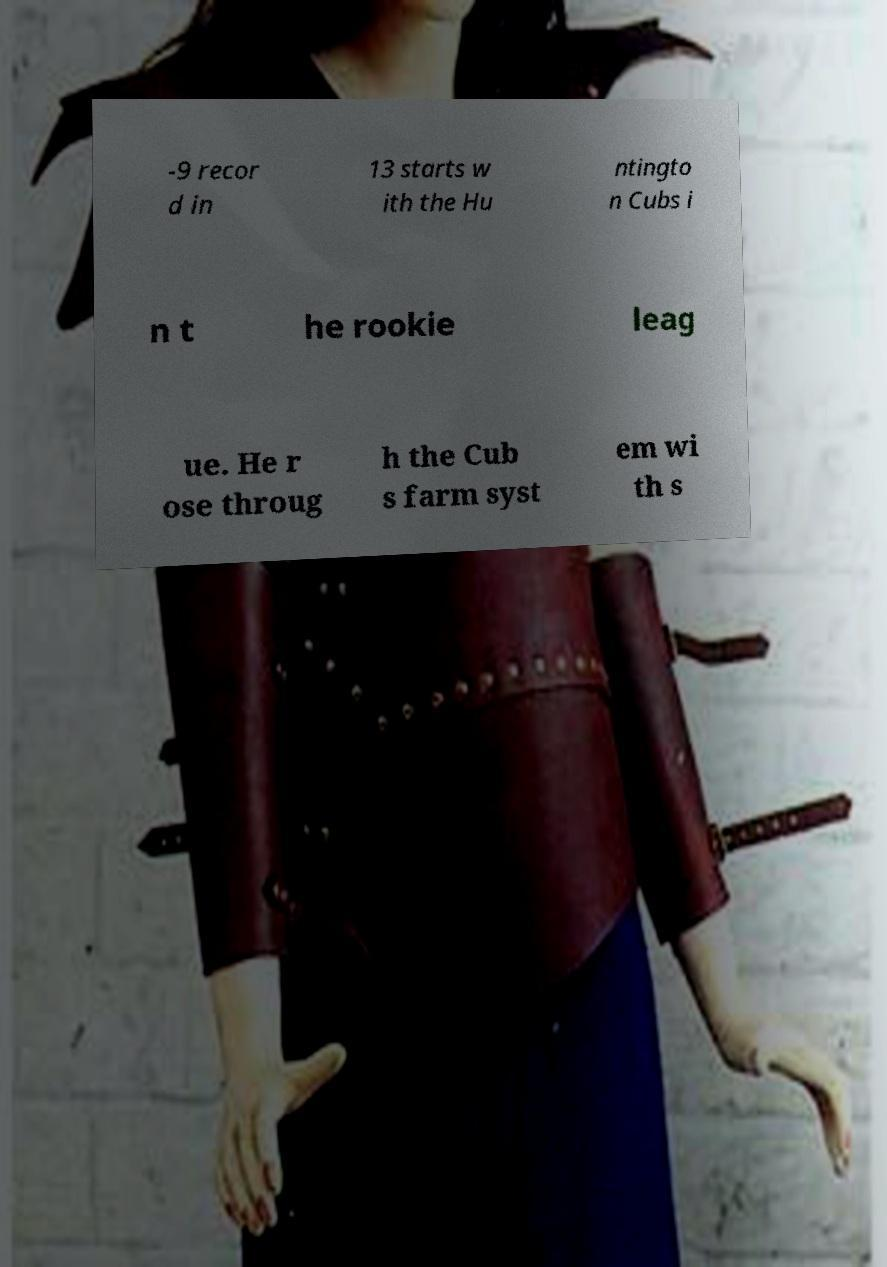Please identify and transcribe the text found in this image. -9 recor d in 13 starts w ith the Hu ntingto n Cubs i n t he rookie leag ue. He r ose throug h the Cub s farm syst em wi th s 